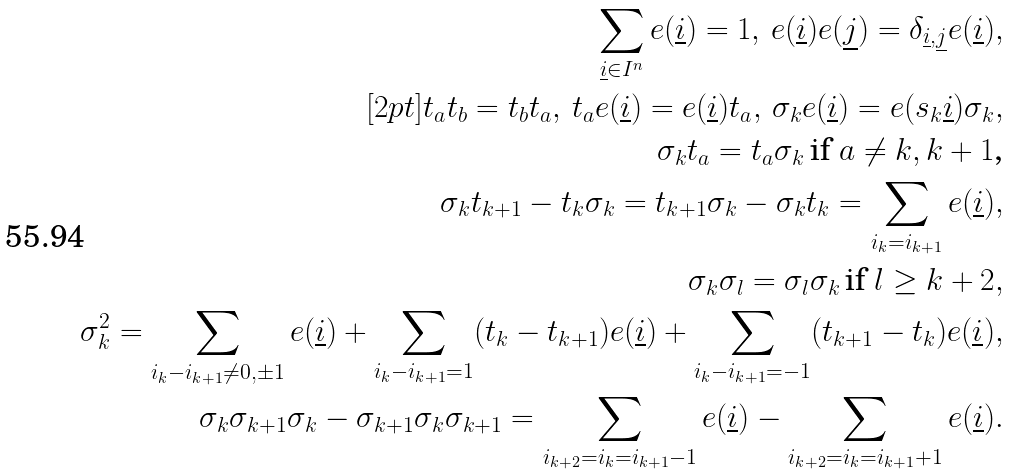<formula> <loc_0><loc_0><loc_500><loc_500>\sum _ { \underline { i } \in I ^ { n } } e ( \underline { i } ) = 1 , \, e ( \underline { i } ) e ( \underline { j } ) = \delta _ { \underline { i } , \underline { j } } e ( \underline { i } ) , \\ [ 2 p t ] t _ { a } t _ { b } = t _ { b } t _ { a } , \, t _ { a } e ( \underline { i } ) = e ( \underline { i } ) t _ { a } , \, \sigma _ { k } e ( \underline { i } ) = e ( s _ { k } \underline { i } ) \sigma _ { k } , \\ \sigma _ { k } t _ { a } = t _ { a } \sigma _ { k } \, \text {if $a\neq k,k+1$,} \\ \sigma _ { k } t _ { k + 1 } - t _ { k } \sigma _ { k } = t _ { k + 1 } \sigma _ { k } - \sigma _ { k } t _ { k } = \sum _ { i _ { k } = i _ { k + 1 } } e ( \underline { i } ) , \\ \sigma _ { k } \sigma _ { l } = \sigma _ { l } \sigma _ { k } \, \text {if $l\geq k+2$} , \\ \sigma _ { k } ^ { 2 } = \sum _ { i _ { k } - i _ { k + 1 } \neq 0 , \pm 1 } e ( \underline { i } ) + \sum _ { i _ { k } - i _ { k + 1 } = 1 } ( t _ { k } - t _ { k + 1 } ) e ( \underline { i } ) + \sum _ { i _ { k } - i _ { k + 1 } = - 1 } ( t _ { k + 1 } - t _ { k } ) e ( \underline { i } ) , \\ \sigma _ { k } \sigma _ { k + 1 } \sigma _ { k } - \sigma _ { k + 1 } \sigma _ { k } \sigma _ { k + 1 } = \sum _ { i _ { k + 2 } = i _ { k } = i _ { k + 1 } - 1 } e ( \underline { i } ) - \sum _ { i _ { k + 2 } = i _ { k } = i _ { k + 1 } + 1 } e ( \underline { i } ) .</formula> 